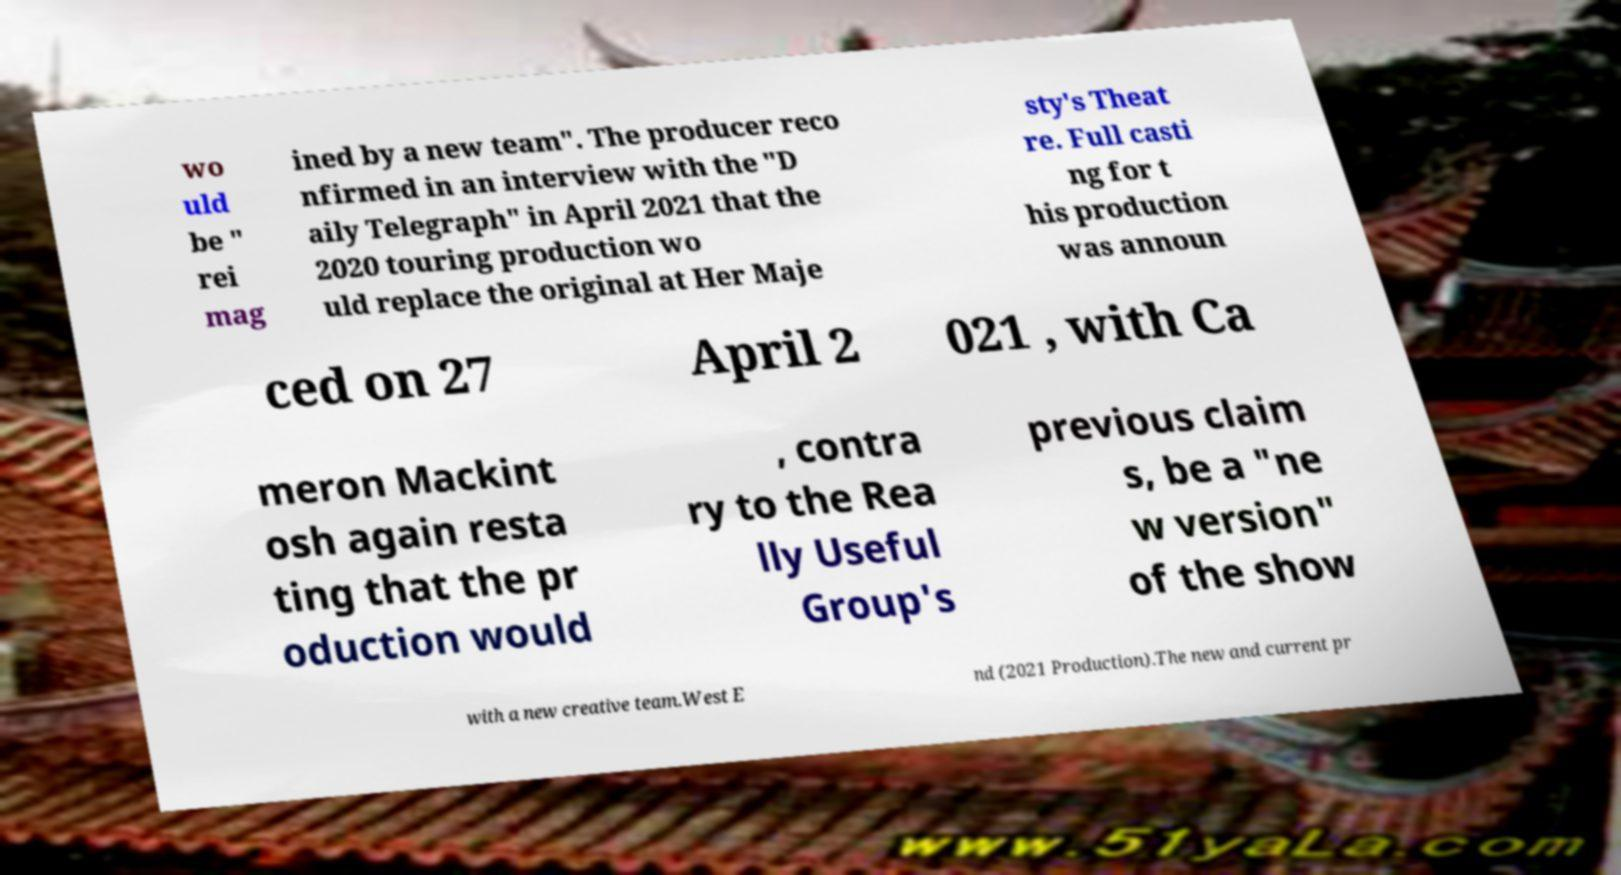Could you extract and type out the text from this image? wo uld be " rei mag ined by a new team". The producer reco nfirmed in an interview with the "D aily Telegraph" in April 2021 that the 2020 touring production wo uld replace the original at Her Maje sty's Theat re. Full casti ng for t his production was announ ced on 27 April 2 021 , with Ca meron Mackint osh again resta ting that the pr oduction would , contra ry to the Rea lly Useful Group's previous claim s, be a "ne w version" of the show with a new creative team.West E nd (2021 Production).The new and current pr 